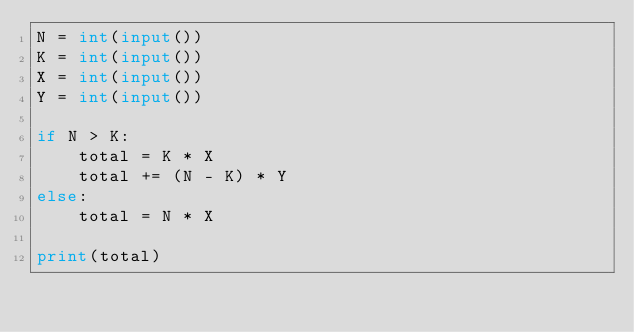Convert code to text. <code><loc_0><loc_0><loc_500><loc_500><_Python_>N = int(input())
K = int(input())
X = int(input())
Y = int(input())

if N > K:
    total = K * X
    total += (N - K) * Y
else:
    total = N * X

print(total)</code> 